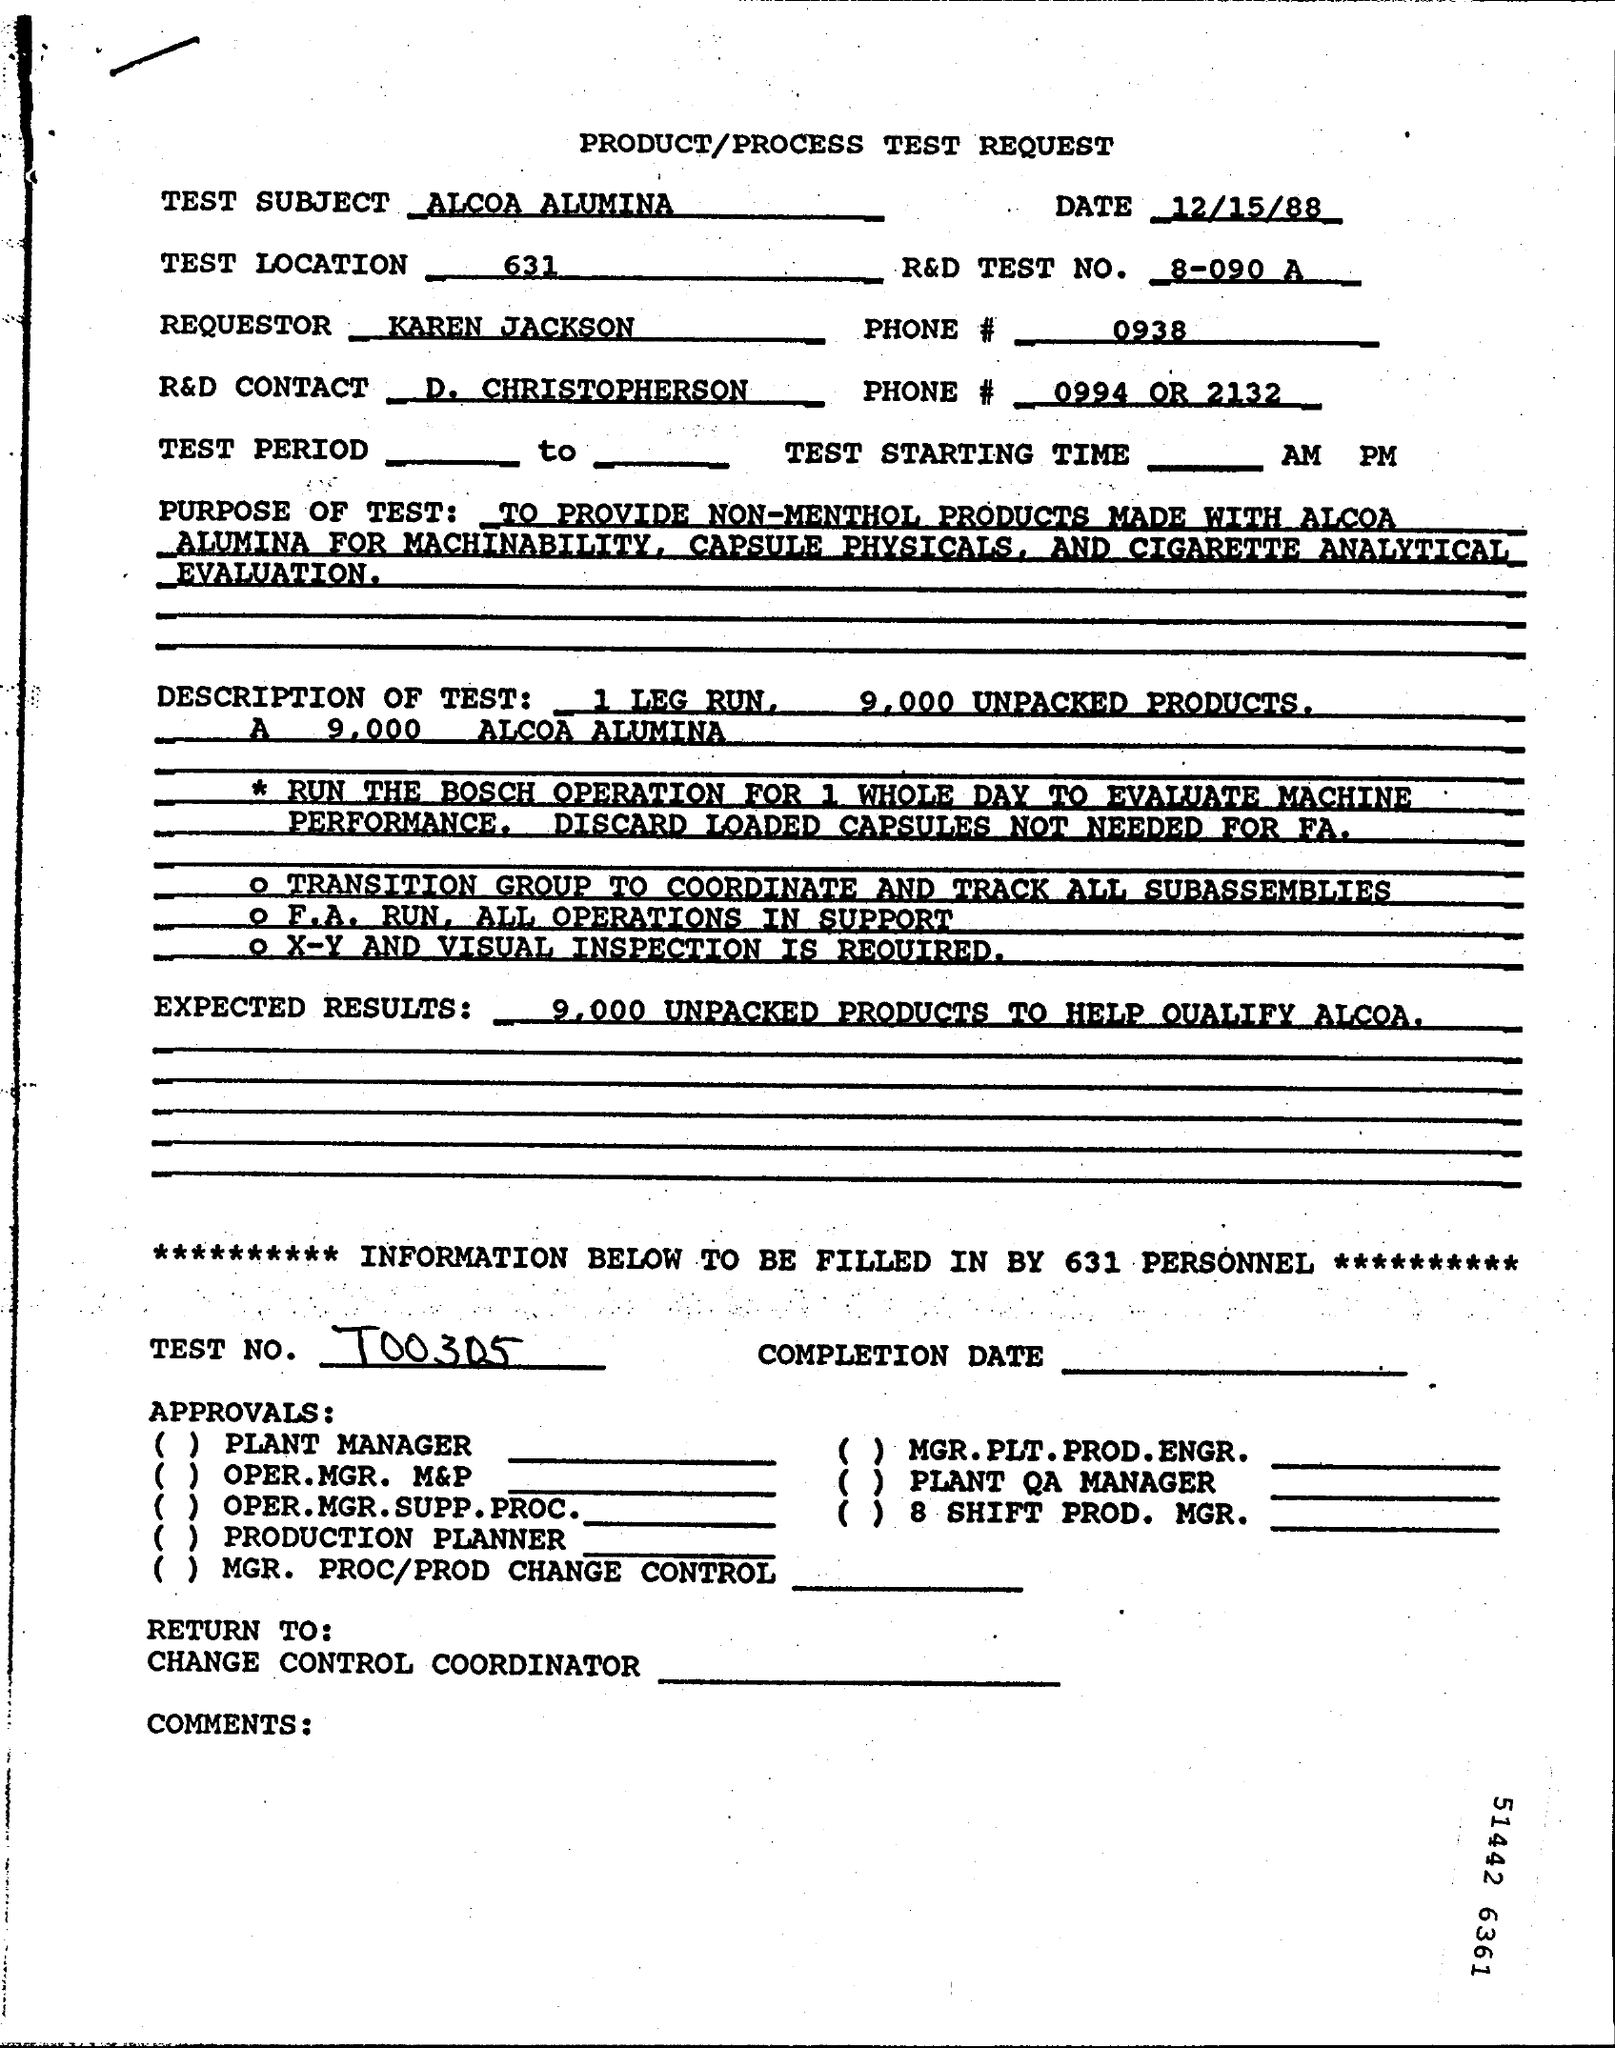What is the Test Location given
Your answer should be compact. 631. What is date of test request
Give a very brief answer. 12/15/88. 